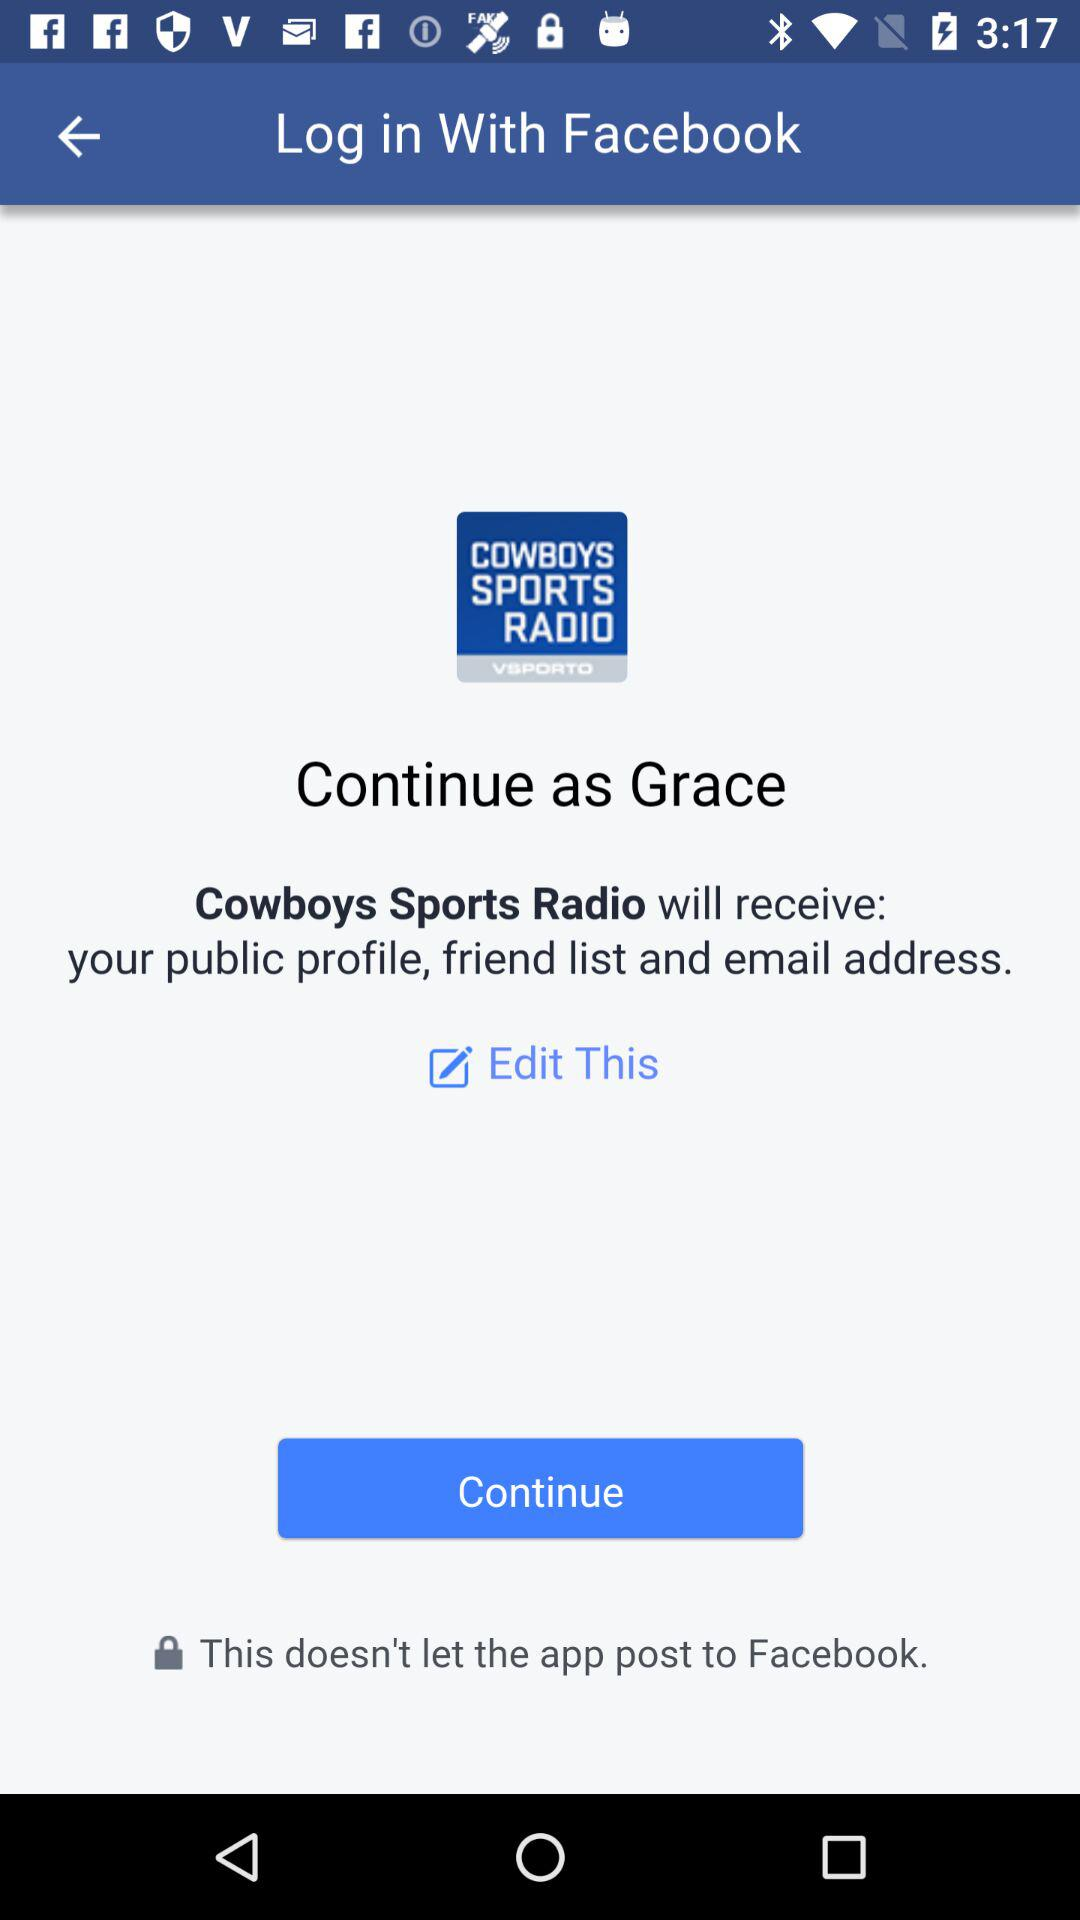What information will "Cowboys Sports Radio" application receive? The application "Cowboys Sports Radio" will receive your public profile, friend list and email address. 